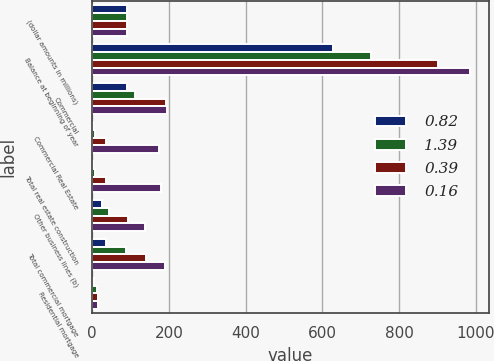Convert chart. <chart><loc_0><loc_0><loc_500><loc_500><stacked_bar_chart><ecel><fcel>(dollar amounts in millions)<fcel>Balance at beginning of year<fcel>Commercial<fcel>Commercial Real Estate<fcel>Total real estate construction<fcel>Other business lines (b)<fcel>Total commercial mortgage<fcel>Residential mortgage<nl><fcel>0.82<fcel>90<fcel>629<fcel>91<fcel>3<fcel>3<fcel>26<fcel>36<fcel>4<nl><fcel>1.39<fcel>90<fcel>726<fcel>112<fcel>7<fcel>8<fcel>43<fcel>89<fcel>13<nl><fcel>0.39<fcel>90<fcel>901<fcel>192<fcel>35<fcel>37<fcel>93<fcel>139<fcel>15<nl><fcel>0.16<fcel>90<fcel>985<fcel>195<fcel>175<fcel>179<fcel>138<fcel>191<fcel>14<nl></chart> 